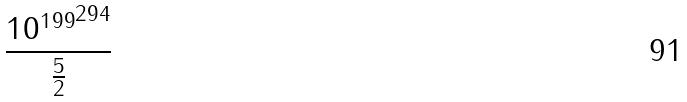Convert formula to latex. <formula><loc_0><loc_0><loc_500><loc_500>\frac { { 1 0 ^ { 1 9 9 } } ^ { 2 9 4 } } { \frac { 5 } { 2 } }</formula> 